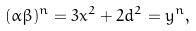<formula> <loc_0><loc_0><loc_500><loc_500>( \alpha \beta ) ^ { n } = 3 x ^ { 2 } + 2 d ^ { 2 } = y ^ { n } ,</formula> 